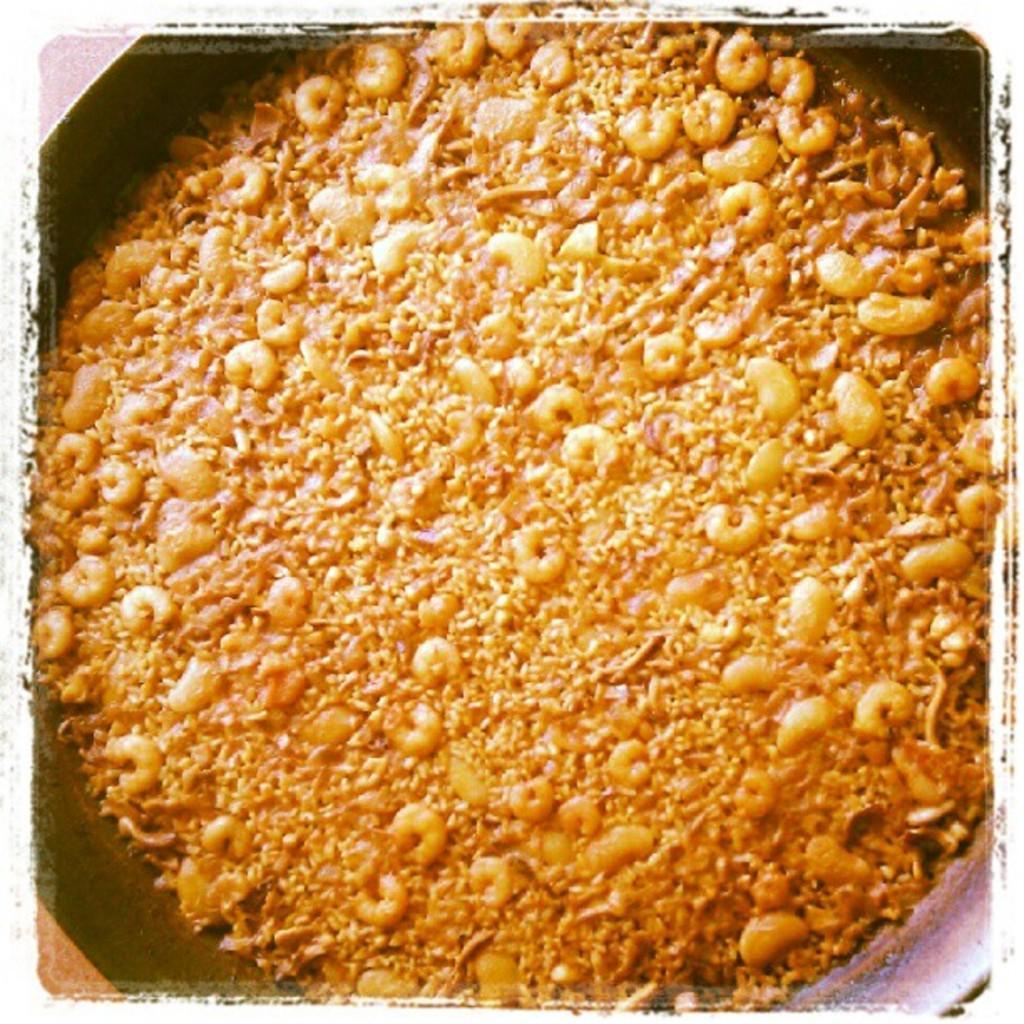In one or two sentences, can you explain what this image depicts? In this picture there is a pan in the center of the image, which contains food items in it, it seems to be prawns in it. 